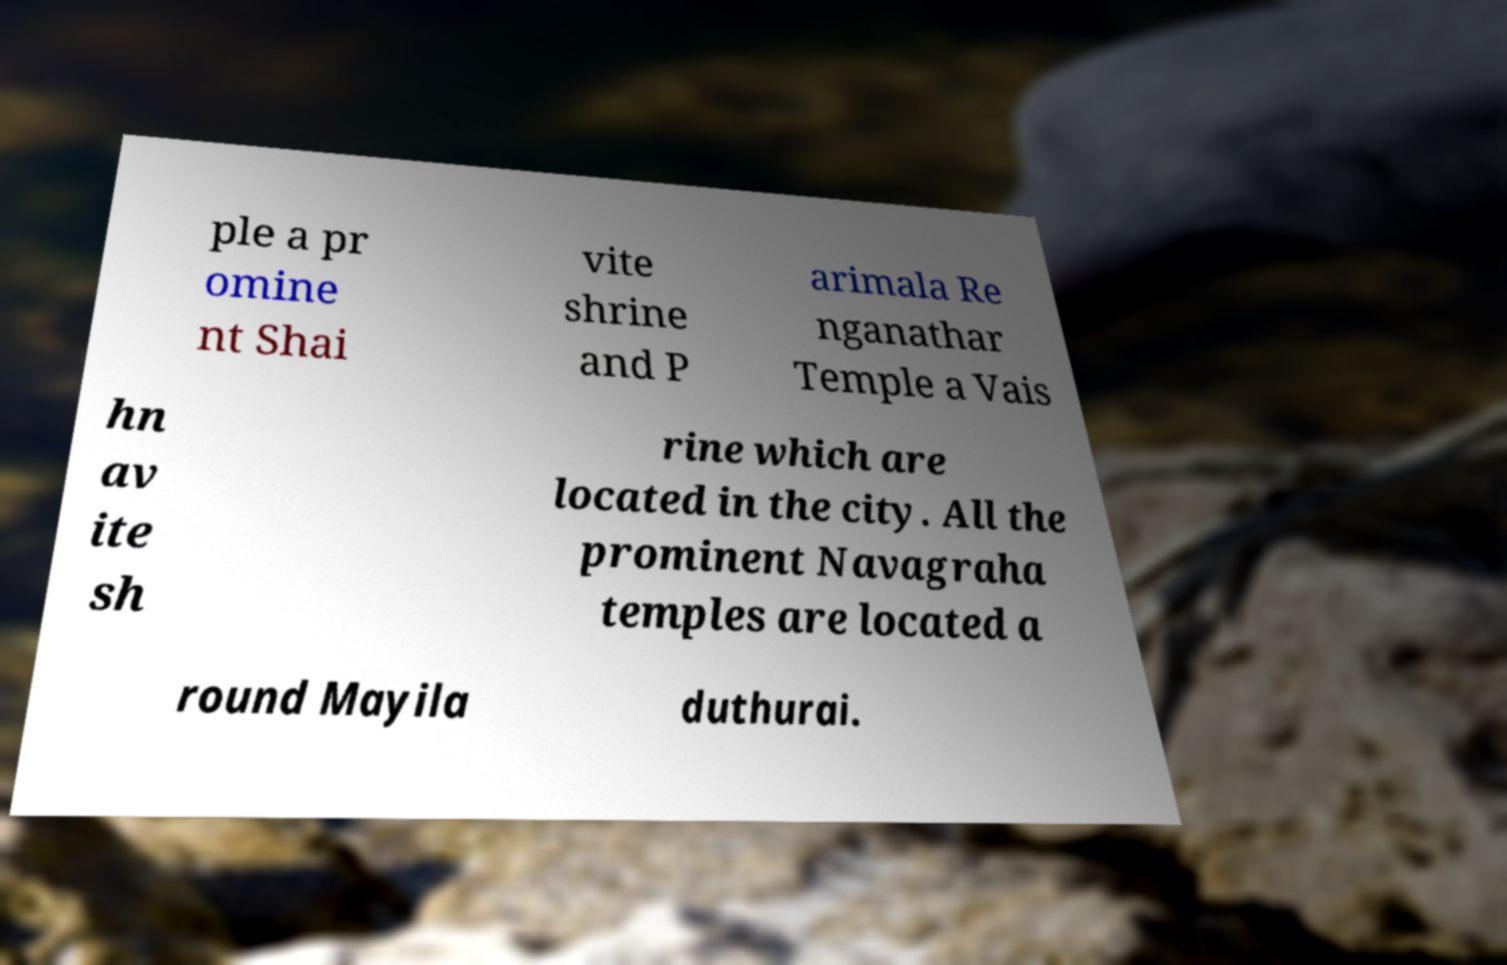Could you extract and type out the text from this image? ple a pr omine nt Shai vite shrine and P arimala Re nganathar Temple a Vais hn av ite sh rine which are located in the city. All the prominent Navagraha temples are located a round Mayila duthurai. 